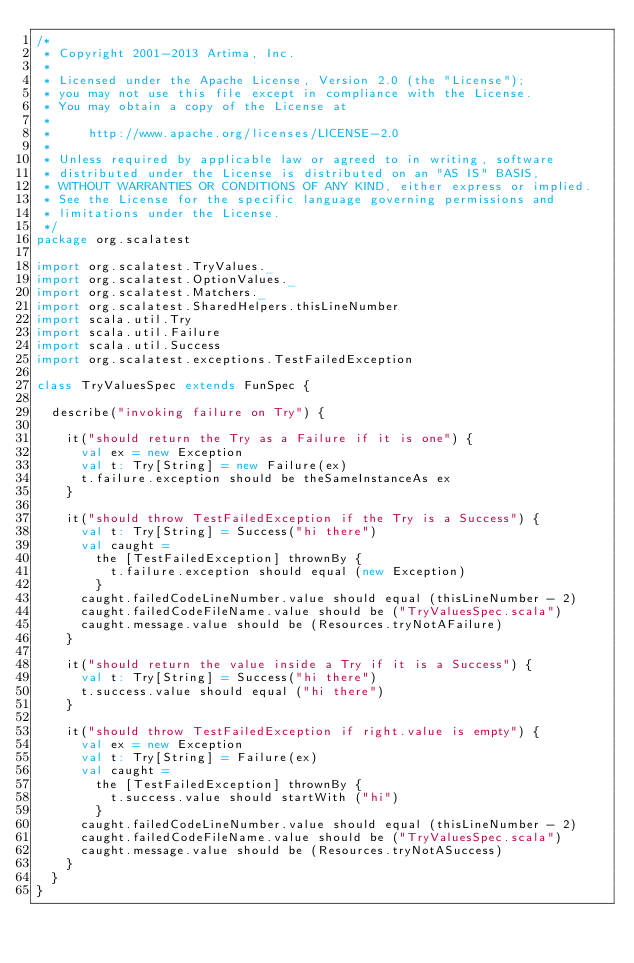Convert code to text. <code><loc_0><loc_0><loc_500><loc_500><_Scala_>/*
 * Copyright 2001-2013 Artima, Inc.
 *
 * Licensed under the Apache License, Version 2.0 (the "License");
 * you may not use this file except in compliance with the License.
 * You may obtain a copy of the License at
 *
 *     http://www.apache.org/licenses/LICENSE-2.0
 *
 * Unless required by applicable law or agreed to in writing, software
 * distributed under the License is distributed on an "AS IS" BASIS,
 * WITHOUT WARRANTIES OR CONDITIONS OF ANY KIND, either express or implied.
 * See the License for the specific language governing permissions and
 * limitations under the License.
 */
package org.scalatest

import org.scalatest.TryValues._
import org.scalatest.OptionValues._
import org.scalatest.Matchers._
import org.scalatest.SharedHelpers.thisLineNumber
import scala.util.Try
import scala.util.Failure
import scala.util.Success
import org.scalatest.exceptions.TestFailedException

class TryValuesSpec extends FunSpec {

  describe("invoking failure on Try") {

    it("should return the Try as a Failure if it is one") {
      val ex = new Exception
      val t: Try[String] = new Failure(ex)
      t.failure.exception should be theSameInstanceAs ex
    }

    it("should throw TestFailedException if the Try is a Success") {
      val t: Try[String] = Success("hi there")
      val caught = 
        the [TestFailedException] thrownBy {
          t.failure.exception should equal (new Exception)
        }
      caught.failedCodeLineNumber.value should equal (thisLineNumber - 2)
      caught.failedCodeFileName.value should be ("TryValuesSpec.scala")
      caught.message.value should be (Resources.tryNotAFailure)
    }

    it("should return the value inside a Try if it is a Success") {
      val t: Try[String] = Success("hi there")
      t.success.value should equal ("hi there")
    }

    it("should throw TestFailedException if right.value is empty") {
      val ex = new Exception
      val t: Try[String] = Failure(ex)
      val caught = 
        the [TestFailedException] thrownBy {
          t.success.value should startWith ("hi")
        }
      caught.failedCodeLineNumber.value should equal (thisLineNumber - 2)
      caught.failedCodeFileName.value should be ("TryValuesSpec.scala")
      caught.message.value should be (Resources.tryNotASuccess)
    }
  } 
}

</code> 